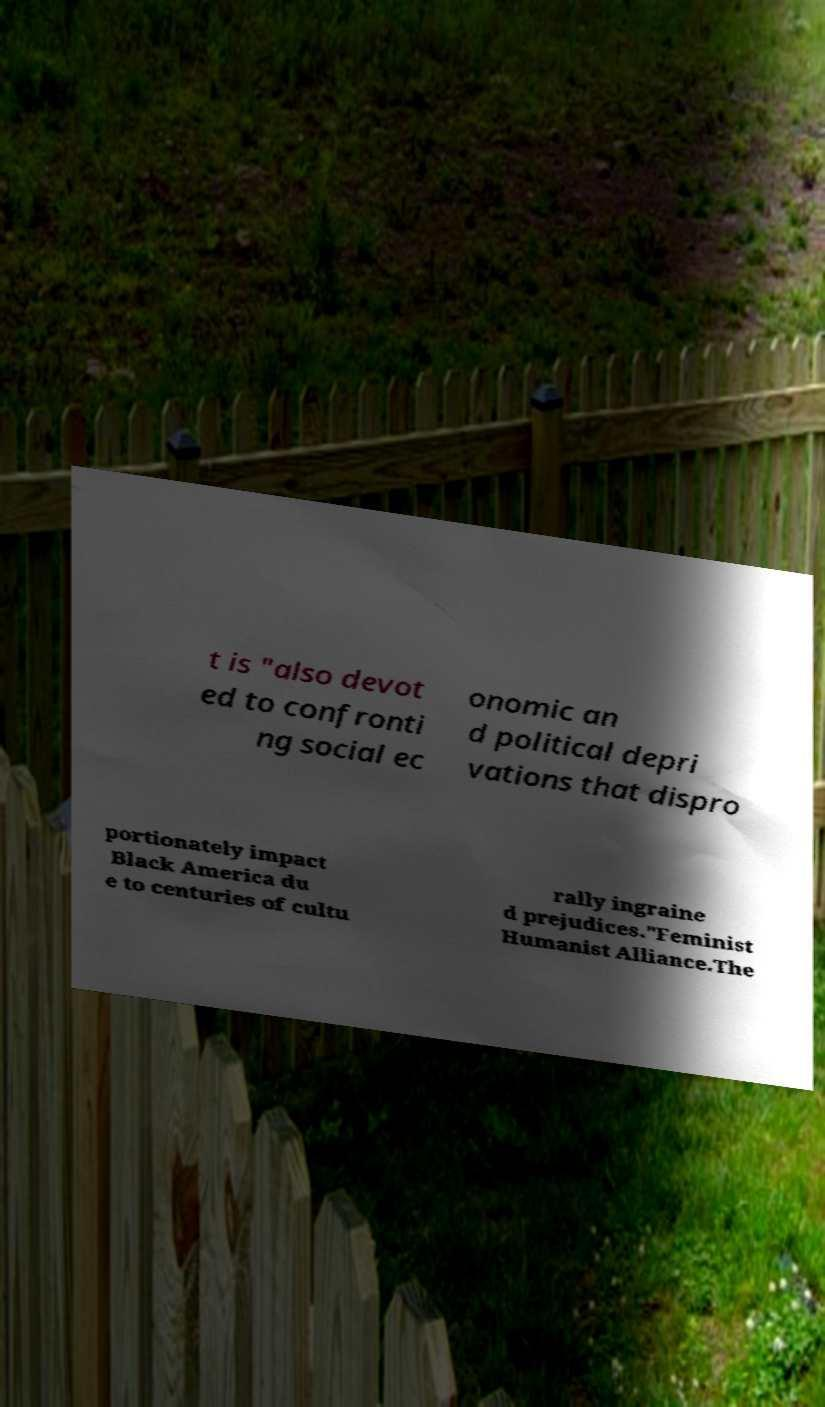I need the written content from this picture converted into text. Can you do that? t is "also devot ed to confronti ng social ec onomic an d political depri vations that dispro portionately impact Black America du e to centuries of cultu rally ingraine d prejudices."Feminist Humanist Alliance.The 